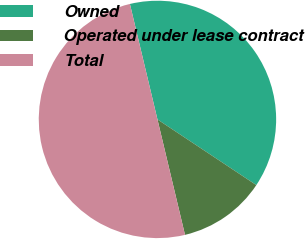Convert chart. <chart><loc_0><loc_0><loc_500><loc_500><pie_chart><fcel>Owned<fcel>Operated under lease contract<fcel>Total<nl><fcel>38.06%<fcel>11.94%<fcel>50.0%<nl></chart> 